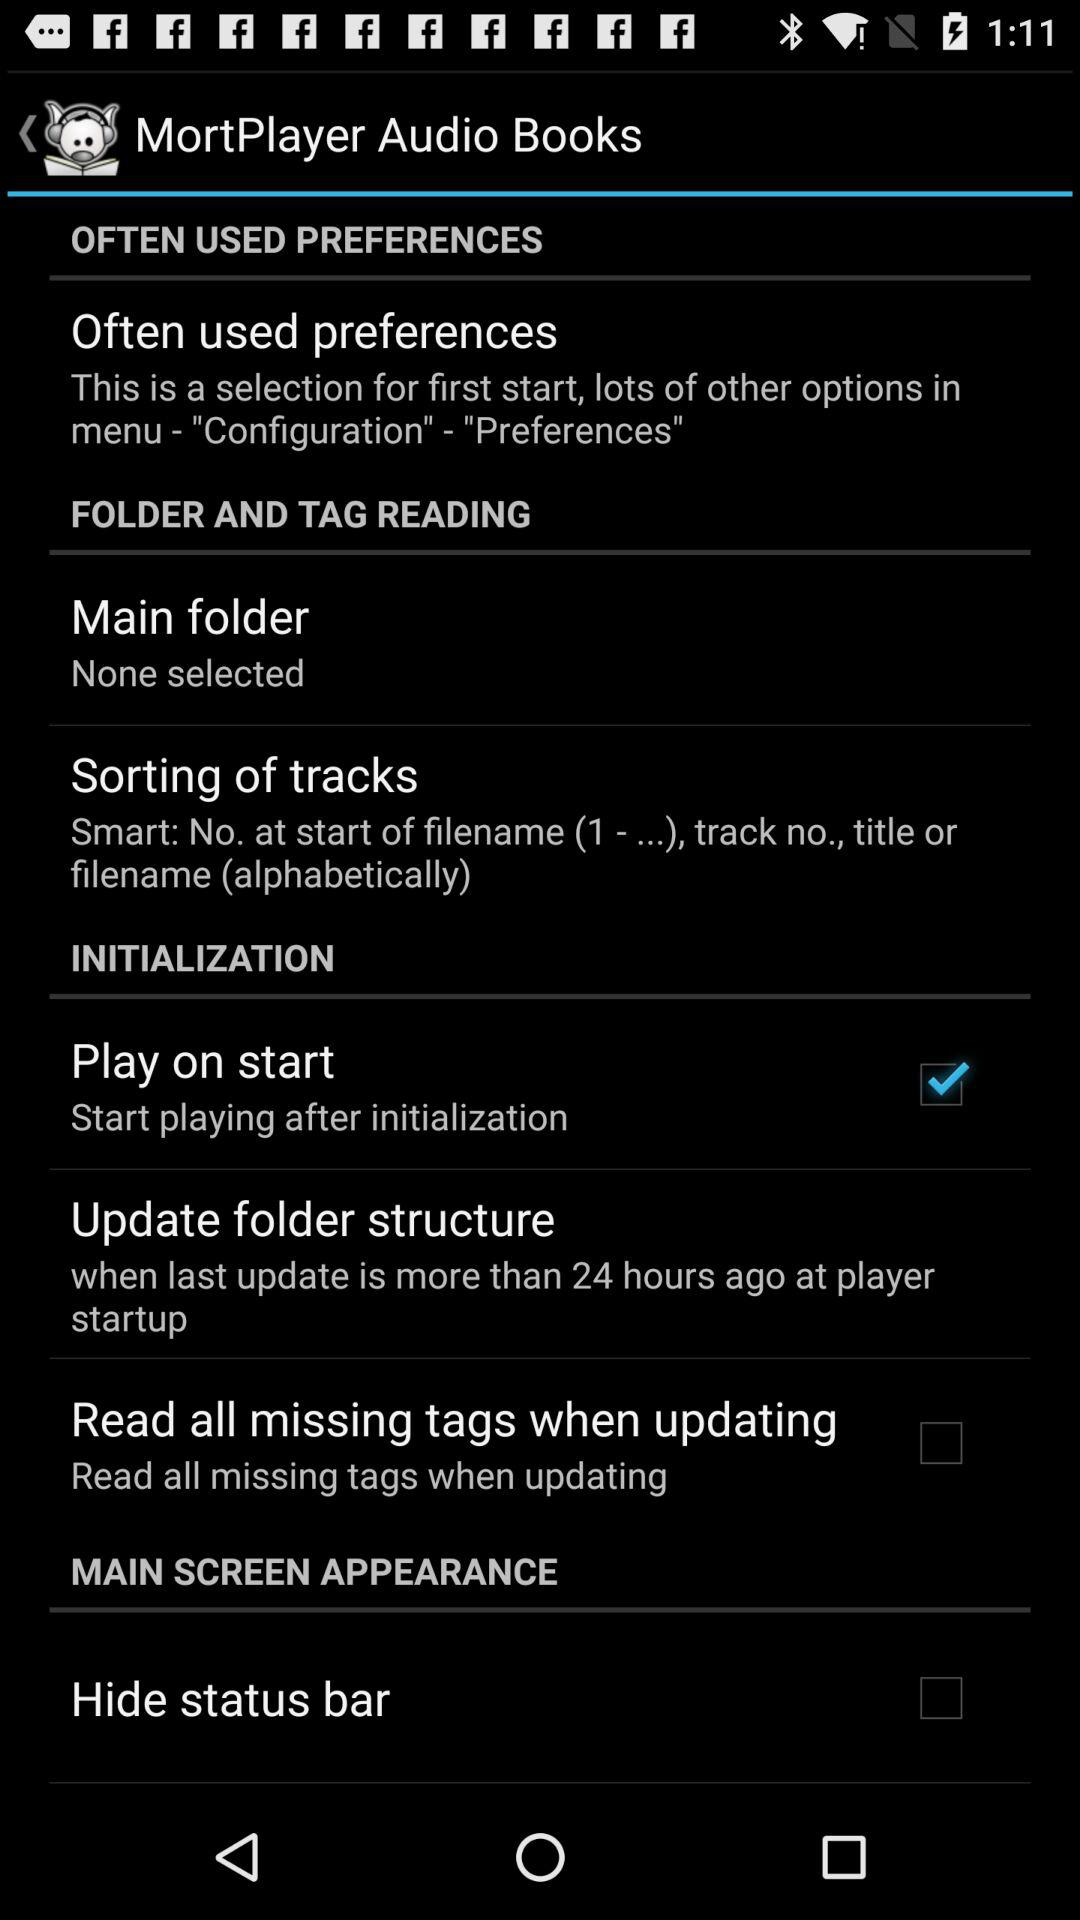How many items are in the Initialization section?
Answer the question using a single word or phrase. 3 